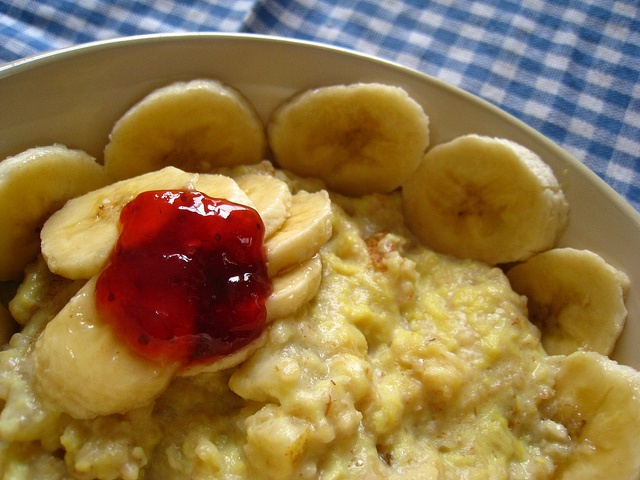Describe the objects in this image and their specific colors. I can see bowl in gray, olive, maroon, and tan tones, banana in gray, olive, and maroon tones, dining table in gray and darkgray tones, banana in gray, olive, and tan tones, and banana in gray, olive, maroon, and tan tones in this image. 